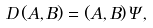<formula> <loc_0><loc_0><loc_500><loc_500>D \, ( A , B ) = ( A , B ) \, \Psi ,</formula> 